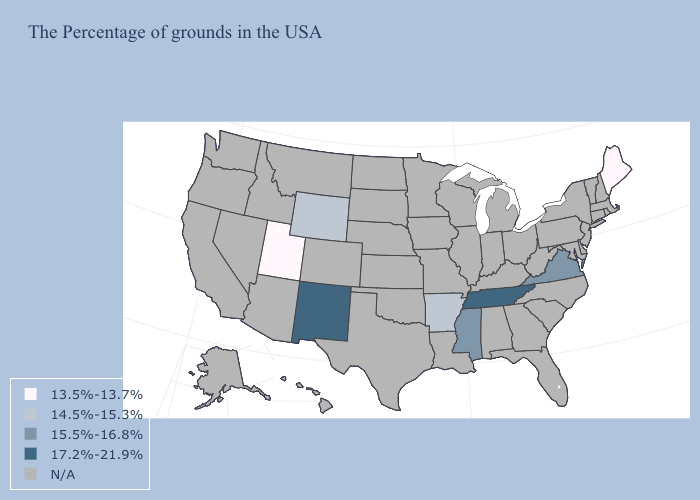What is the value of Maine?
Short answer required. 13.5%-13.7%. Does Utah have the highest value in the USA?
Keep it brief. No. Name the states that have a value in the range 13.5%-13.7%?
Write a very short answer. Maine, Utah. Does the map have missing data?
Short answer required. Yes. What is the lowest value in states that border Nevada?
Write a very short answer. 13.5%-13.7%. How many symbols are there in the legend?
Short answer required. 5. What is the value of New Jersey?
Short answer required. N/A. What is the value of Montana?
Quick response, please. N/A. Among the states that border Idaho , which have the highest value?
Answer briefly. Wyoming. What is the value of Pennsylvania?
Answer briefly. N/A. 